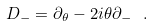<formula> <loc_0><loc_0><loc_500><loc_500>D _ { - } = \partial _ { \theta } - 2 i \theta \partial _ { - } \ .</formula> 